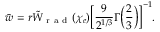Convert formula to latex. <formula><loc_0><loc_0><loc_500><loc_500>\bar { w } = r \tilde { W } _ { r a d } ( \chi _ { e } ) \left [ \frac { 9 } { 2 ^ { 1 / 3 } } \Gamma \left ( \frac { 2 } { 3 } \right ) \right ] ^ { - 1 } .</formula> 